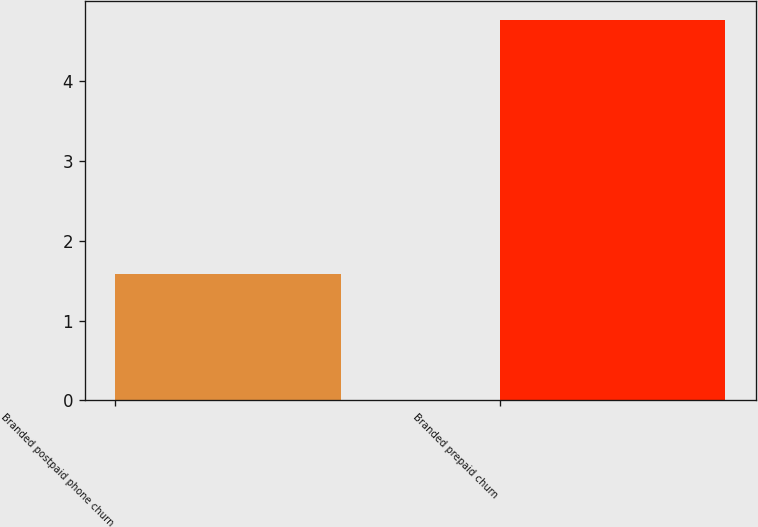<chart> <loc_0><loc_0><loc_500><loc_500><bar_chart><fcel>Branded postpaid phone churn<fcel>Branded prepaid churn<nl><fcel>1.58<fcel>4.76<nl></chart> 